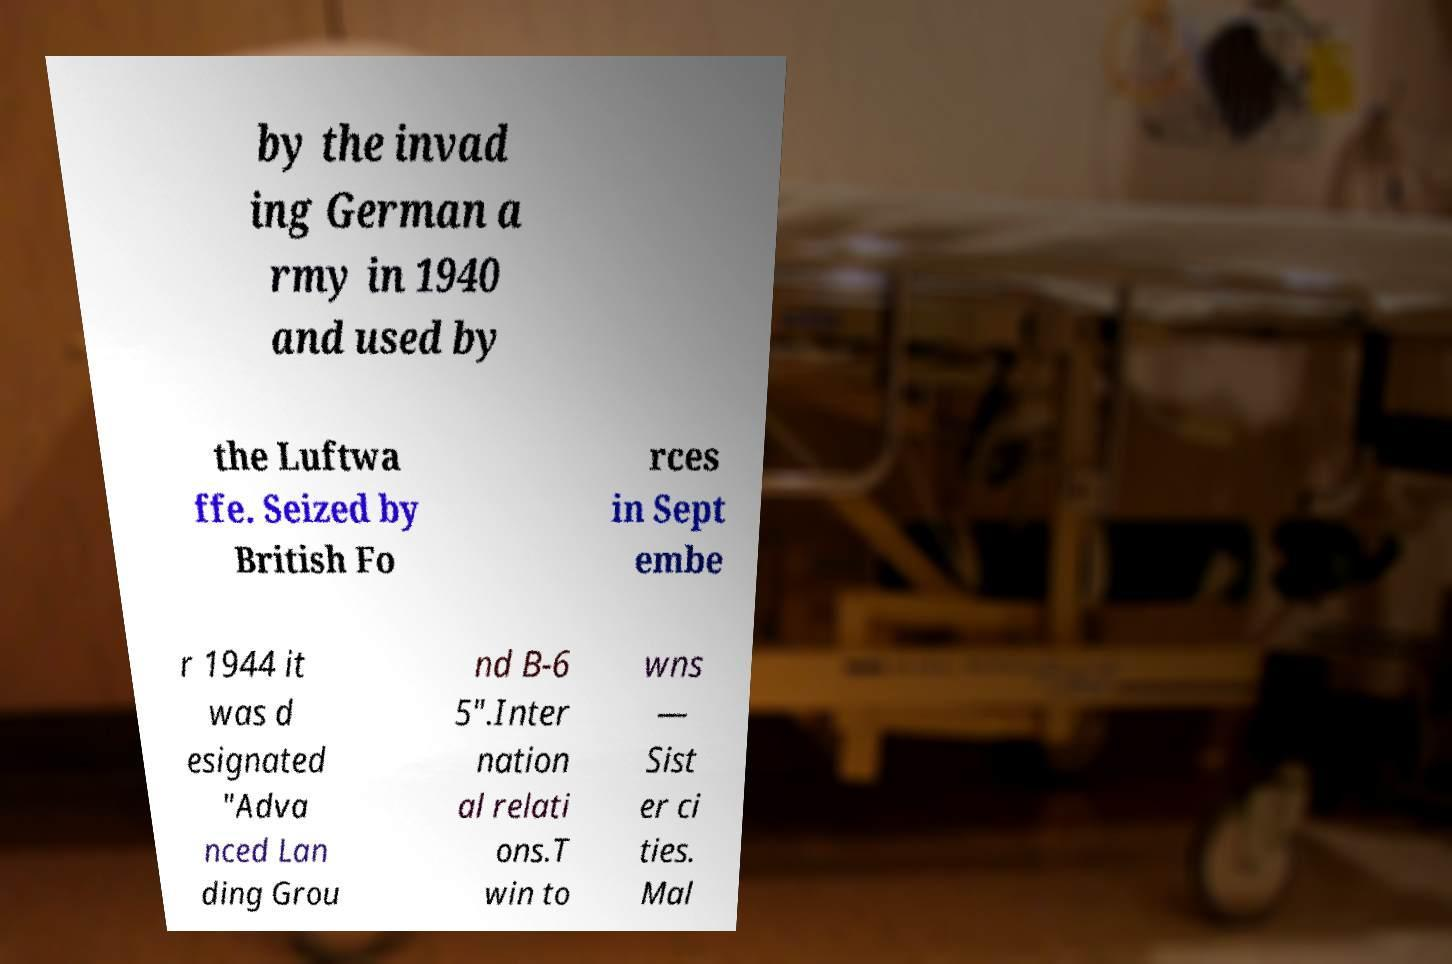Can you accurately transcribe the text from the provided image for me? by the invad ing German a rmy in 1940 and used by the Luftwa ffe. Seized by British Fo rces in Sept embe r 1944 it was d esignated "Adva nced Lan ding Grou nd B-6 5".Inter nation al relati ons.T win to wns — Sist er ci ties. Mal 